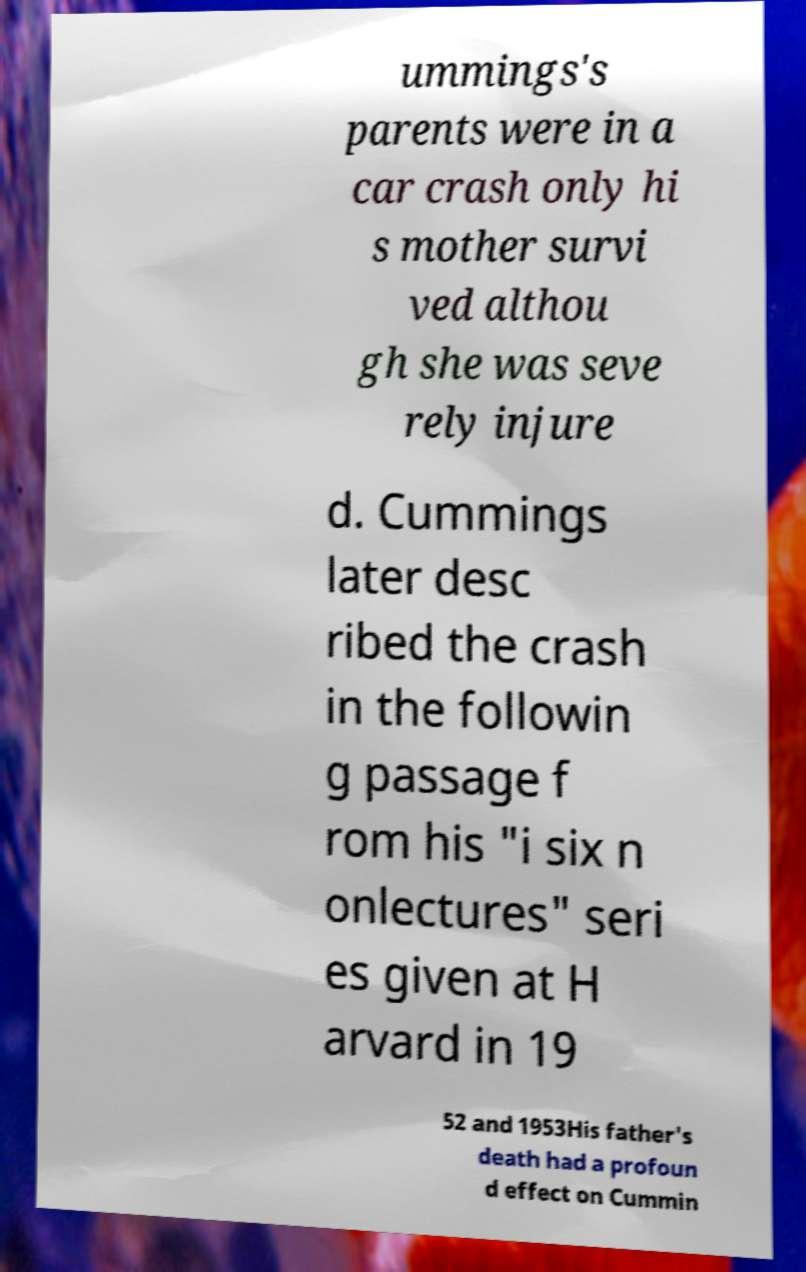I need the written content from this picture converted into text. Can you do that? ummings's parents were in a car crash only hi s mother survi ved althou gh she was seve rely injure d. Cummings later desc ribed the crash in the followin g passage f rom his "i six n onlectures" seri es given at H arvard in 19 52 and 1953His father's death had a profoun d effect on Cummin 